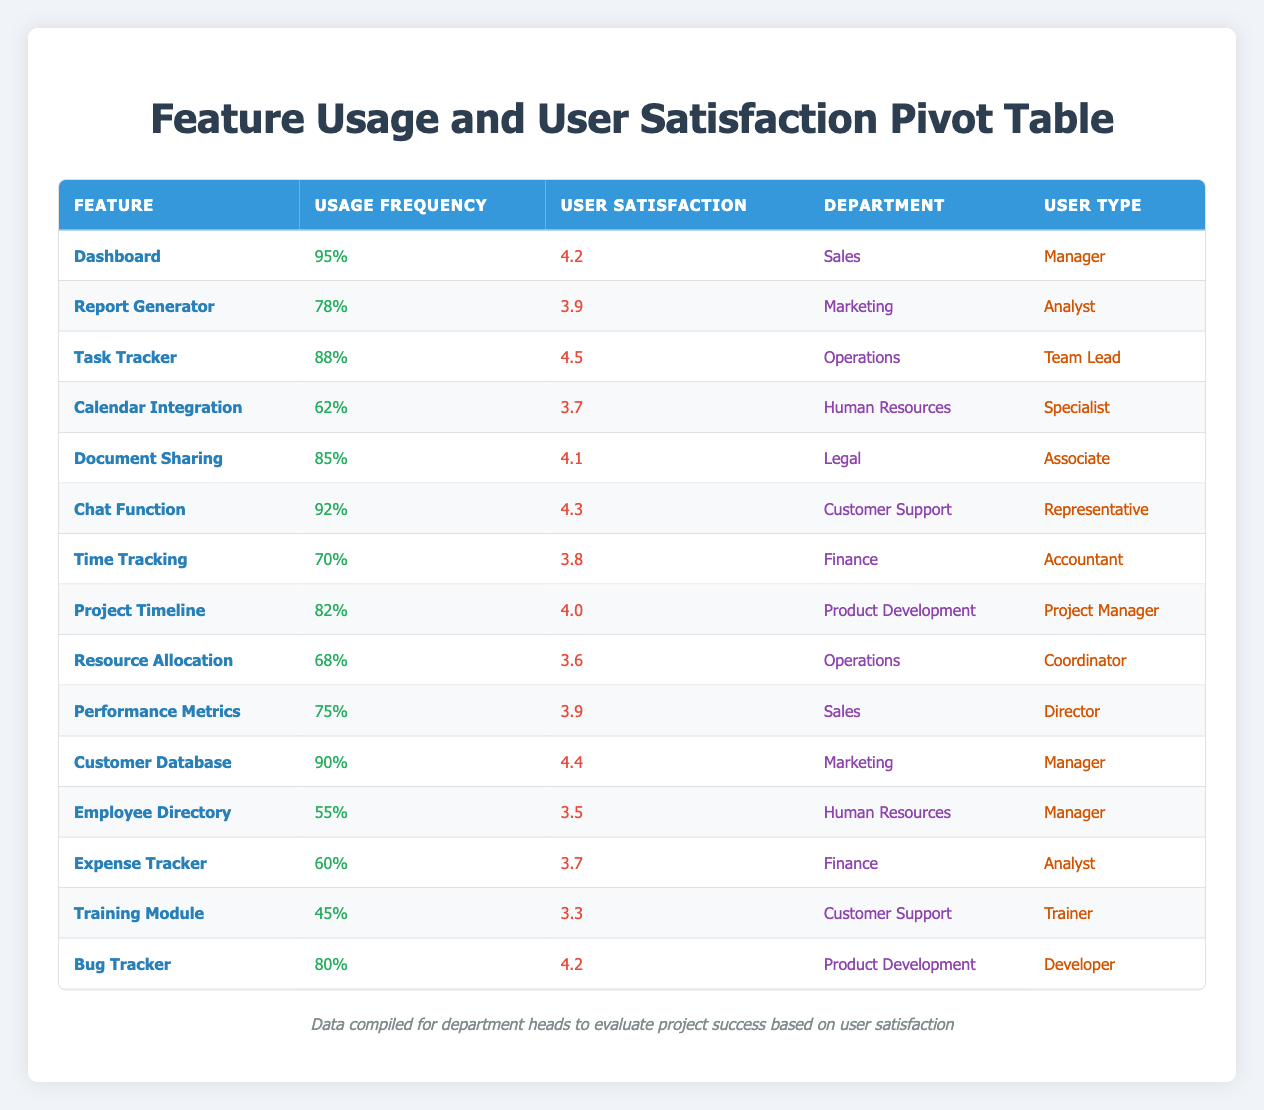What is the user satisfaction rating for the Document Sharing feature? The Document Sharing feature has a user satisfaction rating listed in the table as 4.1.
Answer: 4.1 Which feature has the highest usage frequency? The feature with the highest usage frequency is the Dashboard, recorded at 95%.
Answer: Dashboard What is the average user satisfaction rating for the features used by the Finance department? The Finance department has three features: Time Tracking (3.8), Expense Tracker (3.7), and the average is calculated as (3.8 + 3.7) / 2 = 3.75.
Answer: 3.75 Is the user satisfaction rating for the Calendar Integration feature above 4.0? The Calendar Integration feature has a user satisfaction rating of 3.7, which is below 4.0, hence the answer is no.
Answer: No Which user type has the highest-rated feature in terms of user satisfaction? The highest user satisfaction rating is 4.5, which corresponds to the Task Tracker used by the Team Lead in the Operations department.
Answer: Team Lead What is the difference in usage frequency between the Chat Function and Performance Metrics? The usage frequency for the Chat Function is 92% and for Performance Metrics is 75%. The difference is calculated as 92 - 75 = 17.
Answer: 17 Which departments have features with a user satisfaction rating below 3.6? The departments Human Resources (Employee Directory, 3.5) and Operations (Resource Allocation, 3.6) have features with user satisfaction ratings below 3.6.
Answer: Human Resources, Operations What is the total usage frequency of features in the Customer Support department? The Customer Support department has two features: Chat Function (92%) and Training Module (45%). Adding these gives 92 + 45 = 137.
Answer: 137 Which feature has a higher user satisfaction, Bug Tracker or Report Generator? The user satisfaction rating for Bug Tracker is 4.2, while for Report Generator it is 3.9. Since 4.2 is greater than 3.9, Bug Tracker has a higher user satisfaction rating.
Answer: Bug Tracker 